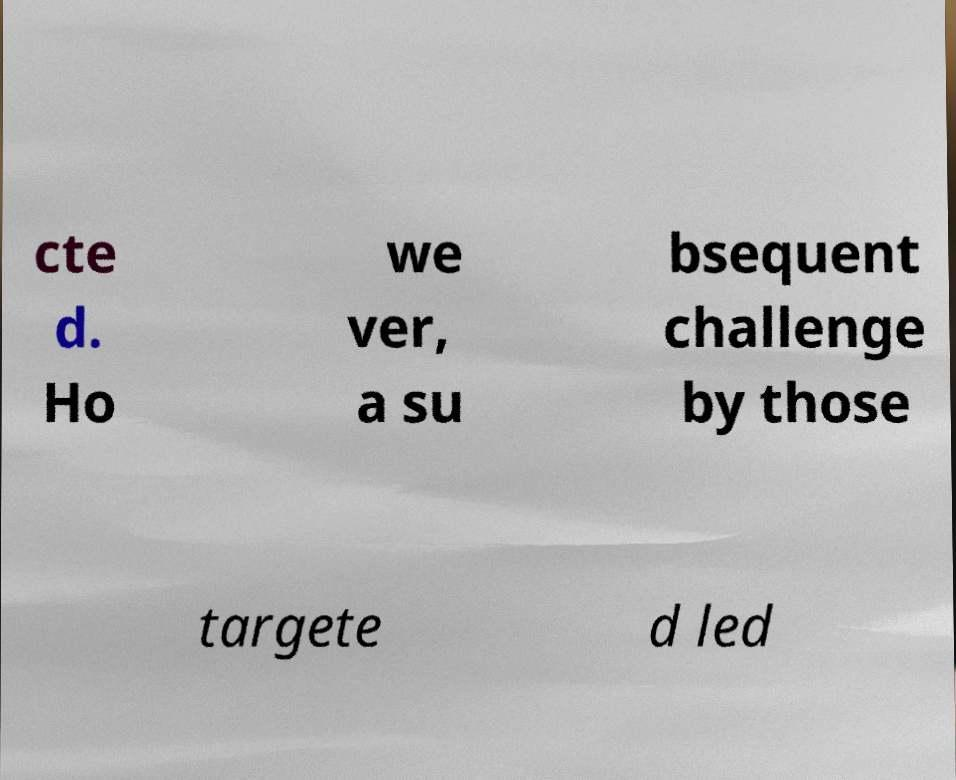Can you accurately transcribe the text from the provided image for me? cte d. Ho we ver, a su bsequent challenge by those targete d led 